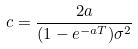<formula> <loc_0><loc_0><loc_500><loc_500>c = \frac { 2 a } { ( 1 - e ^ { - a T } ) \sigma ^ { 2 } }</formula> 